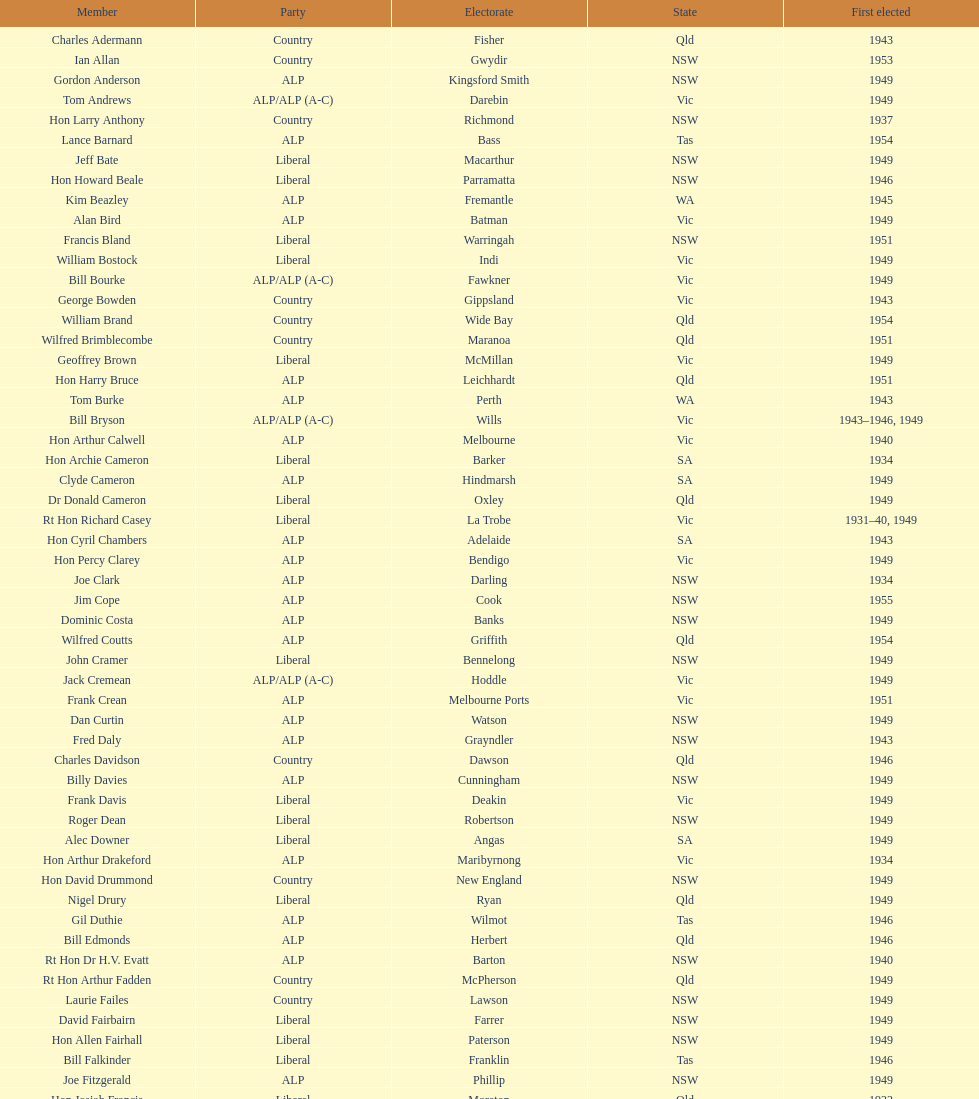Would you be able to parse every entry in this table? {'header': ['Member', 'Party', 'Electorate', 'State', 'First elected'], 'rows': [['Charles Adermann', 'Country', 'Fisher', 'Qld', '1943'], ['Ian Allan', 'Country', 'Gwydir', 'NSW', '1953'], ['Gordon Anderson', 'ALP', 'Kingsford Smith', 'NSW', '1949'], ['Tom Andrews', 'ALP/ALP (A-C)', 'Darebin', 'Vic', '1949'], ['Hon Larry Anthony', 'Country', 'Richmond', 'NSW', '1937'], ['Lance Barnard', 'ALP', 'Bass', 'Tas', '1954'], ['Jeff Bate', 'Liberal', 'Macarthur', 'NSW', '1949'], ['Hon Howard Beale', 'Liberal', 'Parramatta', 'NSW', '1946'], ['Kim Beazley', 'ALP', 'Fremantle', 'WA', '1945'], ['Alan Bird', 'ALP', 'Batman', 'Vic', '1949'], ['Francis Bland', 'Liberal', 'Warringah', 'NSW', '1951'], ['William Bostock', 'Liberal', 'Indi', 'Vic', '1949'], ['Bill Bourke', 'ALP/ALP (A-C)', 'Fawkner', 'Vic', '1949'], ['George Bowden', 'Country', 'Gippsland', 'Vic', '1943'], ['William Brand', 'Country', 'Wide Bay', 'Qld', '1954'], ['Wilfred Brimblecombe', 'Country', 'Maranoa', 'Qld', '1951'], ['Geoffrey Brown', 'Liberal', 'McMillan', 'Vic', '1949'], ['Hon Harry Bruce', 'ALP', 'Leichhardt', 'Qld', '1951'], ['Tom Burke', 'ALP', 'Perth', 'WA', '1943'], ['Bill Bryson', 'ALP/ALP (A-C)', 'Wills', 'Vic', '1943–1946, 1949'], ['Hon Arthur Calwell', 'ALP', 'Melbourne', 'Vic', '1940'], ['Hon Archie Cameron', 'Liberal', 'Barker', 'SA', '1934'], ['Clyde Cameron', 'ALP', 'Hindmarsh', 'SA', '1949'], ['Dr Donald Cameron', 'Liberal', 'Oxley', 'Qld', '1949'], ['Rt Hon Richard Casey', 'Liberal', 'La Trobe', 'Vic', '1931–40, 1949'], ['Hon Cyril Chambers', 'ALP', 'Adelaide', 'SA', '1943'], ['Hon Percy Clarey', 'ALP', 'Bendigo', 'Vic', '1949'], ['Joe Clark', 'ALP', 'Darling', 'NSW', '1934'], ['Jim Cope', 'ALP', 'Cook', 'NSW', '1955'], ['Dominic Costa', 'ALP', 'Banks', 'NSW', '1949'], ['Wilfred Coutts', 'ALP', 'Griffith', 'Qld', '1954'], ['John Cramer', 'Liberal', 'Bennelong', 'NSW', '1949'], ['Jack Cremean', 'ALP/ALP (A-C)', 'Hoddle', 'Vic', '1949'], ['Frank Crean', 'ALP', 'Melbourne Ports', 'Vic', '1951'], ['Dan Curtin', 'ALP', 'Watson', 'NSW', '1949'], ['Fred Daly', 'ALP', 'Grayndler', 'NSW', '1943'], ['Charles Davidson', 'Country', 'Dawson', 'Qld', '1946'], ['Billy Davies', 'ALP', 'Cunningham', 'NSW', '1949'], ['Frank Davis', 'Liberal', 'Deakin', 'Vic', '1949'], ['Roger Dean', 'Liberal', 'Robertson', 'NSW', '1949'], ['Alec Downer', 'Liberal', 'Angas', 'SA', '1949'], ['Hon Arthur Drakeford', 'ALP', 'Maribyrnong', 'Vic', '1934'], ['Hon David Drummond', 'Country', 'New England', 'NSW', '1949'], ['Nigel Drury', 'Liberal', 'Ryan', 'Qld', '1949'], ['Gil Duthie', 'ALP', 'Wilmot', 'Tas', '1946'], ['Bill Edmonds', 'ALP', 'Herbert', 'Qld', '1946'], ['Rt Hon Dr H.V. Evatt', 'ALP', 'Barton', 'NSW', '1940'], ['Rt Hon Arthur Fadden', 'Country', 'McPherson', 'Qld', '1949'], ['Laurie Failes', 'Country', 'Lawson', 'NSW', '1949'], ['David Fairbairn', 'Liberal', 'Farrer', 'NSW', '1949'], ['Hon Allen Fairhall', 'Liberal', 'Paterson', 'NSW', '1949'], ['Bill Falkinder', 'Liberal', 'Franklin', 'Tas', '1946'], ['Joe Fitzgerald', 'ALP', 'Phillip', 'NSW', '1949'], ['Hon Josiah Francis', 'Liberal', 'Moreton', 'Qld', '1922'], ['Allan Fraser', 'ALP', 'Eden-Monaro', 'NSW', '1943'], ['Jim Fraser', 'ALP', 'Australian Capital Territory', 'ACT', '1951'], ['Gordon Freeth', 'Liberal', 'Forrest', 'WA', '1949'], ['Arthur Fuller', 'Country', 'Hume', 'NSW', '1943–49, 1951'], ['Pat Galvin', 'ALP', 'Kingston', 'SA', '1951'], ['Arthur Greenup', 'ALP', 'Dalley', 'NSW', '1953'], ['Charles Griffiths', 'ALP', 'Shortland', 'NSW', '1949'], ['Jo Gullett', 'Liberal', 'Henty', 'Vic', '1946'], ['Len Hamilton', 'Country', 'Canning', 'WA', '1946'], ['Rt Hon Eric Harrison', 'Liberal', 'Wentworth', 'NSW', '1931'], ['Jim Harrison', 'ALP', 'Blaxland', 'NSW', '1949'], ['Hon Paul Hasluck', 'Liberal', 'Curtin', 'WA', '1949'], ['Hon William Haworth', 'Liberal', 'Isaacs', 'Vic', '1949'], ['Leslie Haylen', 'ALP', 'Parkes', 'NSW', '1943'], ['Rt Hon Harold Holt', 'Liberal', 'Higgins', 'Vic', '1935'], ['John Howse', 'Liberal', 'Calare', 'NSW', '1946'], ['Alan Hulme', 'Liberal', 'Petrie', 'Qld', '1949'], ['William Jack', 'Liberal', 'North Sydney', 'NSW', '1949'], ['Rowley James', 'ALP', 'Hunter', 'NSW', '1928'], ['Hon Herbert Johnson', 'ALP', 'Kalgoorlie', 'WA', '1940'], ['Bob Joshua', 'ALP/ALP (A-C)', 'Ballaarat', 'ALP', '1951'], ['Percy Joske', 'Liberal', 'Balaclava', 'Vic', '1951'], ['Hon Wilfrid Kent Hughes', 'Liberal', 'Chisholm', 'Vic', '1949'], ['Stan Keon', 'ALP/ALP (A-C)', 'Yarra', 'Vic', '1949'], ['William Lawrence', 'Liberal', 'Wimmera', 'Vic', '1949'], ['Hon George Lawson', 'ALP', 'Brisbane', 'Qld', '1931'], ['Nelson Lemmon', 'ALP', 'St George', 'NSW', '1943–49, 1954'], ['Hugh Leslie', 'Liberal', 'Moore', 'Country', '1949'], ['Robert Lindsay', 'Liberal', 'Flinders', 'Vic', '1954'], ['Tony Luchetti', 'ALP', 'Macquarie', 'NSW', '1951'], ['Aubrey Luck', 'Liberal', 'Darwin', 'Tas', '1951'], ['Philip Lucock', 'Country', 'Lyne', 'NSW', '1953'], ['Dan Mackinnon', 'Liberal', 'Corangamite', 'Vic', '1949–51, 1953'], ['Hon Norman Makin', 'ALP', 'Sturt', 'SA', '1919–46, 1954'], ['Hon Philip McBride', 'Liberal', 'Wakefield', 'SA', '1931–37, 1937–43 (S), 1946'], ['Malcolm McColm', 'Liberal', 'Bowman', 'Qld', '1949'], ['Rt Hon John McEwen', 'Country', 'Murray', 'Vic', '1934'], ['John McLeay', 'Liberal', 'Boothby', 'SA', '1949'], ['Don McLeod', 'Liberal', 'Wannon', 'ALP', '1940–49, 1951'], ['Hon William McMahon', 'Liberal', 'Lowe', 'NSW', '1949'], ['Rt Hon Robert Menzies', 'Liberal', 'Kooyong', 'Vic', '1934'], ['Dan Minogue', 'ALP', 'West Sydney', 'NSW', '1949'], ['Charles Morgan', 'ALP', 'Reid', 'NSW', '1940–46, 1949'], ['Jack Mullens', 'ALP/ALP (A-C)', 'Gellibrand', 'Vic', '1949'], ['Jock Nelson', 'ALP', 'Northern Territory', 'NT', '1949'], ["William O'Connor", 'ALP', 'Martin', 'NSW', '1946'], ['Hubert Opperman', 'Liberal', 'Corio', 'Vic', '1949'], ['Hon Frederick Osborne', 'Liberal', 'Evans', 'NSW', '1949'], ['Rt Hon Sir Earle Page', 'Country', 'Cowper', 'NSW', '1919'], ['Henry Pearce', 'Liberal', 'Capricornia', 'Qld', '1949'], ['Ted Peters', 'ALP', 'Burke', 'Vic', '1949'], ['Hon Reg Pollard', 'ALP', 'Lalor', 'Vic', '1937'], ['Hon Bill Riordan', 'ALP', 'Kennedy', 'Qld', '1936'], ['Hugh Roberton', 'Country', 'Riverina', 'NSW', '1949'], ['Edgar Russell', 'ALP', 'Grey', 'SA', '1943'], ['Tom Sheehan', 'ALP', 'Cook', 'NSW', '1937'], ['Frank Stewart', 'ALP', 'Lang', 'NSW', '1953'], ['Reginald Swartz', 'Liberal', 'Darling Downs', 'Qld', '1949'], ['Albert Thompson', 'ALP', 'Port Adelaide', 'SA', '1946'], ['Frank Timson', 'Liberal', 'Higinbotham', 'Vic', '1949'], ['Hon Athol Townley', 'Liberal', 'Denison', 'Tas', '1949'], ['Winton Turnbull', 'Country', 'Mallee', 'Vic', '1946'], ['Harry Turner', 'Liberal', 'Bradfield', 'NSW', '1952'], ['Hon Eddie Ward', 'ALP', 'East Sydney', 'NSW', '1931, 1932'], ['David Oliver Watkins', 'ALP', 'Newcastle', 'NSW', '1935'], ['Harry Webb', 'ALP', 'Swan', 'WA', '1954'], ['William Wentworth', 'Liberal', 'Mackellar', 'NSW', '1949'], ['Roy Wheeler', 'Liberal', 'Mitchell', 'NSW', '1949'], ['Gough Whitlam', 'ALP', 'Werriwa', 'NSW', '1952'], ['Bruce Wight', 'Liberal', 'Lilley', 'Qld', '1949']]} Who was the first member to be elected? Charles Adermann. 